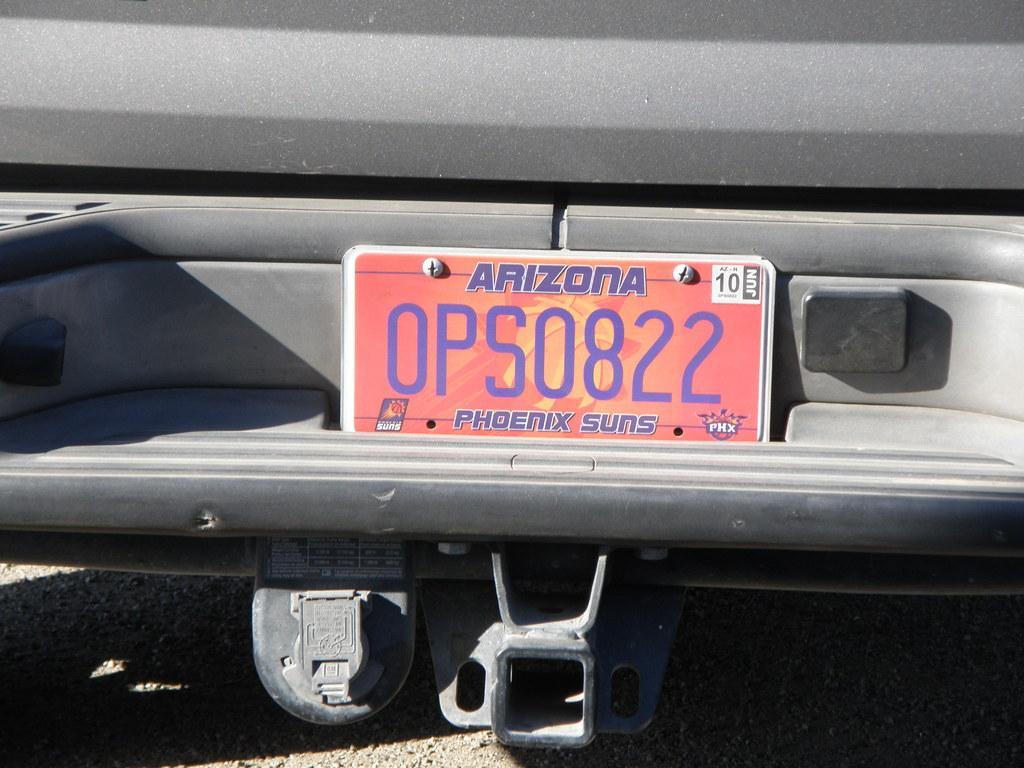Can you describe this image briefly? In this image I can see an ash color object and red and orange color board is attached to it and something is written on it. 